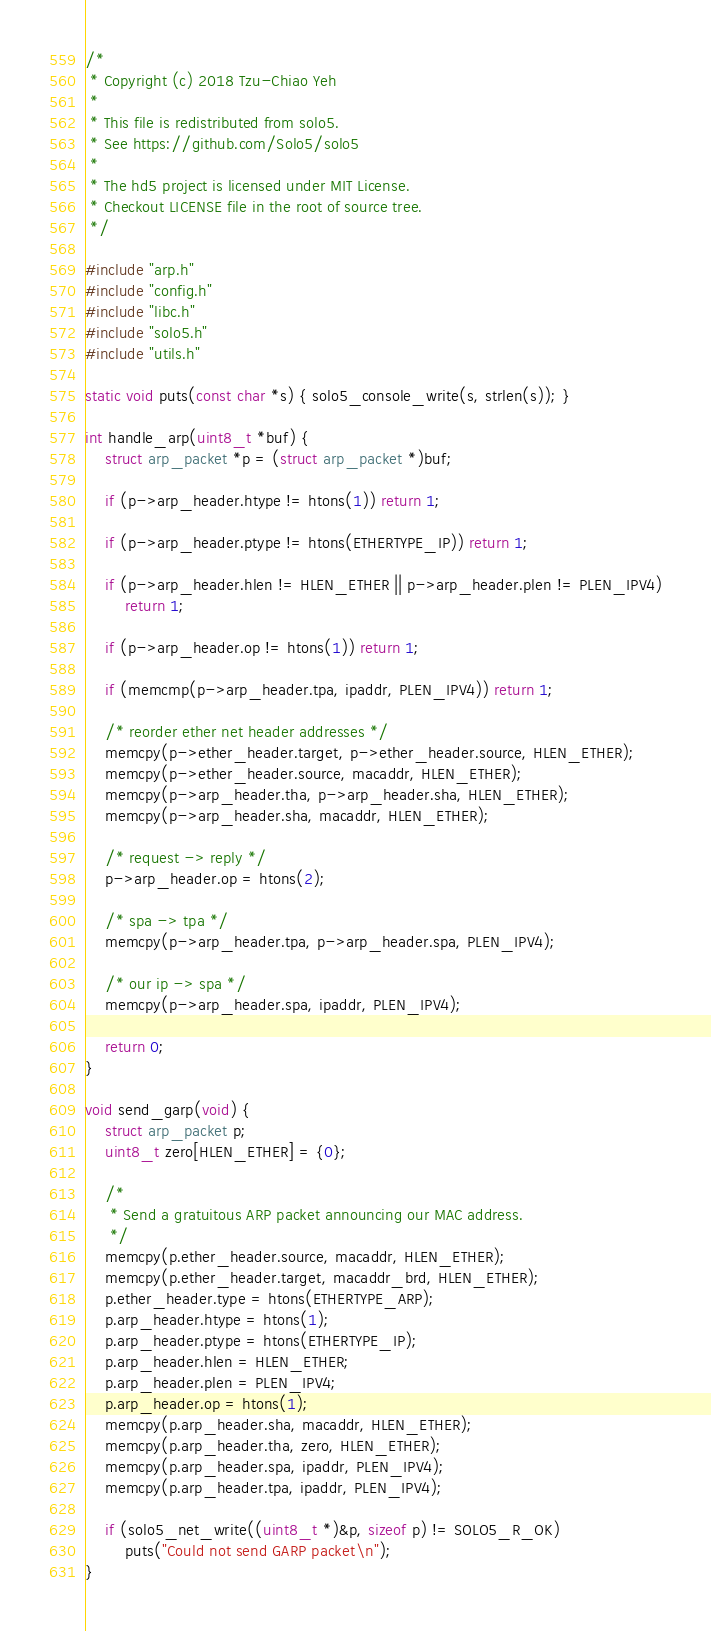Convert code to text. <code><loc_0><loc_0><loc_500><loc_500><_C_>/*
 * Copyright (c) 2018 Tzu-Chiao Yeh
 *
 * This file is redistributed from solo5.
 * See https://github.com/Solo5/solo5
 *
 * The hd5 project is licensed under MIT License.
 * Checkout LICENSE file in the root of source tree.
 */

#include "arp.h"
#include "config.h"
#include "libc.h"
#include "solo5.h"
#include "utils.h"

static void puts(const char *s) { solo5_console_write(s, strlen(s)); }

int handle_arp(uint8_t *buf) {
    struct arp_packet *p = (struct arp_packet *)buf;

    if (p->arp_header.htype != htons(1)) return 1;

    if (p->arp_header.ptype != htons(ETHERTYPE_IP)) return 1;

    if (p->arp_header.hlen != HLEN_ETHER || p->arp_header.plen != PLEN_IPV4)
        return 1;

    if (p->arp_header.op != htons(1)) return 1;

    if (memcmp(p->arp_header.tpa, ipaddr, PLEN_IPV4)) return 1;

    /* reorder ether net header addresses */
    memcpy(p->ether_header.target, p->ether_header.source, HLEN_ETHER);
    memcpy(p->ether_header.source, macaddr, HLEN_ETHER);
    memcpy(p->arp_header.tha, p->arp_header.sha, HLEN_ETHER);
    memcpy(p->arp_header.sha, macaddr, HLEN_ETHER);

    /* request -> reply */
    p->arp_header.op = htons(2);

    /* spa -> tpa */
    memcpy(p->arp_header.tpa, p->arp_header.spa, PLEN_IPV4);

    /* our ip -> spa */
    memcpy(p->arp_header.spa, ipaddr, PLEN_IPV4);

    return 0;
}

void send_garp(void) {
    struct arp_packet p;
    uint8_t zero[HLEN_ETHER] = {0};

    /*
     * Send a gratuitous ARP packet announcing our MAC address.
     */
    memcpy(p.ether_header.source, macaddr, HLEN_ETHER);
    memcpy(p.ether_header.target, macaddr_brd, HLEN_ETHER);
    p.ether_header.type = htons(ETHERTYPE_ARP);
    p.arp_header.htype = htons(1);
    p.arp_header.ptype = htons(ETHERTYPE_IP);
    p.arp_header.hlen = HLEN_ETHER;
    p.arp_header.plen = PLEN_IPV4;
    p.arp_header.op = htons(1);
    memcpy(p.arp_header.sha, macaddr, HLEN_ETHER);
    memcpy(p.arp_header.tha, zero, HLEN_ETHER);
    memcpy(p.arp_header.spa, ipaddr, PLEN_IPV4);
    memcpy(p.arp_header.tpa, ipaddr, PLEN_IPV4);

    if (solo5_net_write((uint8_t *)&p, sizeof p) != SOLO5_R_OK)
        puts("Could not send GARP packet\n");
}
</code> 